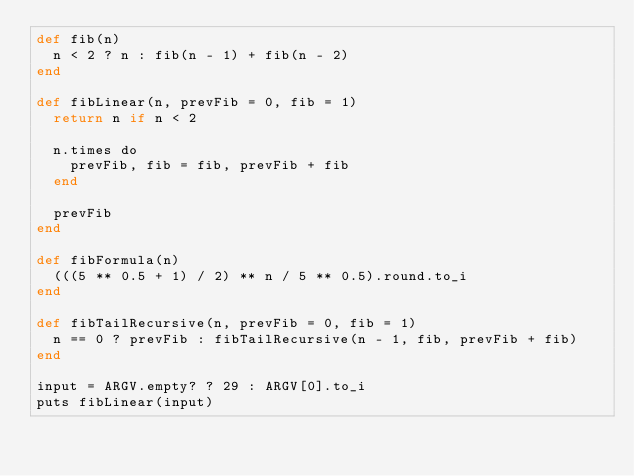Convert code to text. <code><loc_0><loc_0><loc_500><loc_500><_Crystal_>def fib(n)
  n < 2 ? n : fib(n - 1) + fib(n - 2)
end

def fibLinear(n, prevFib = 0, fib = 1)
  return n if n < 2

  n.times do
    prevFib, fib = fib, prevFib + fib
  end

  prevFib
end

def fibFormula(n)
  (((5 ** 0.5 + 1) / 2) ** n / 5 ** 0.5).round.to_i
end

def fibTailRecursive(n, prevFib = 0, fib = 1)
  n == 0 ? prevFib : fibTailRecursive(n - 1, fib, prevFib + fib)
end

input = ARGV.empty? ? 29 : ARGV[0].to_i
puts fibLinear(input)
</code> 